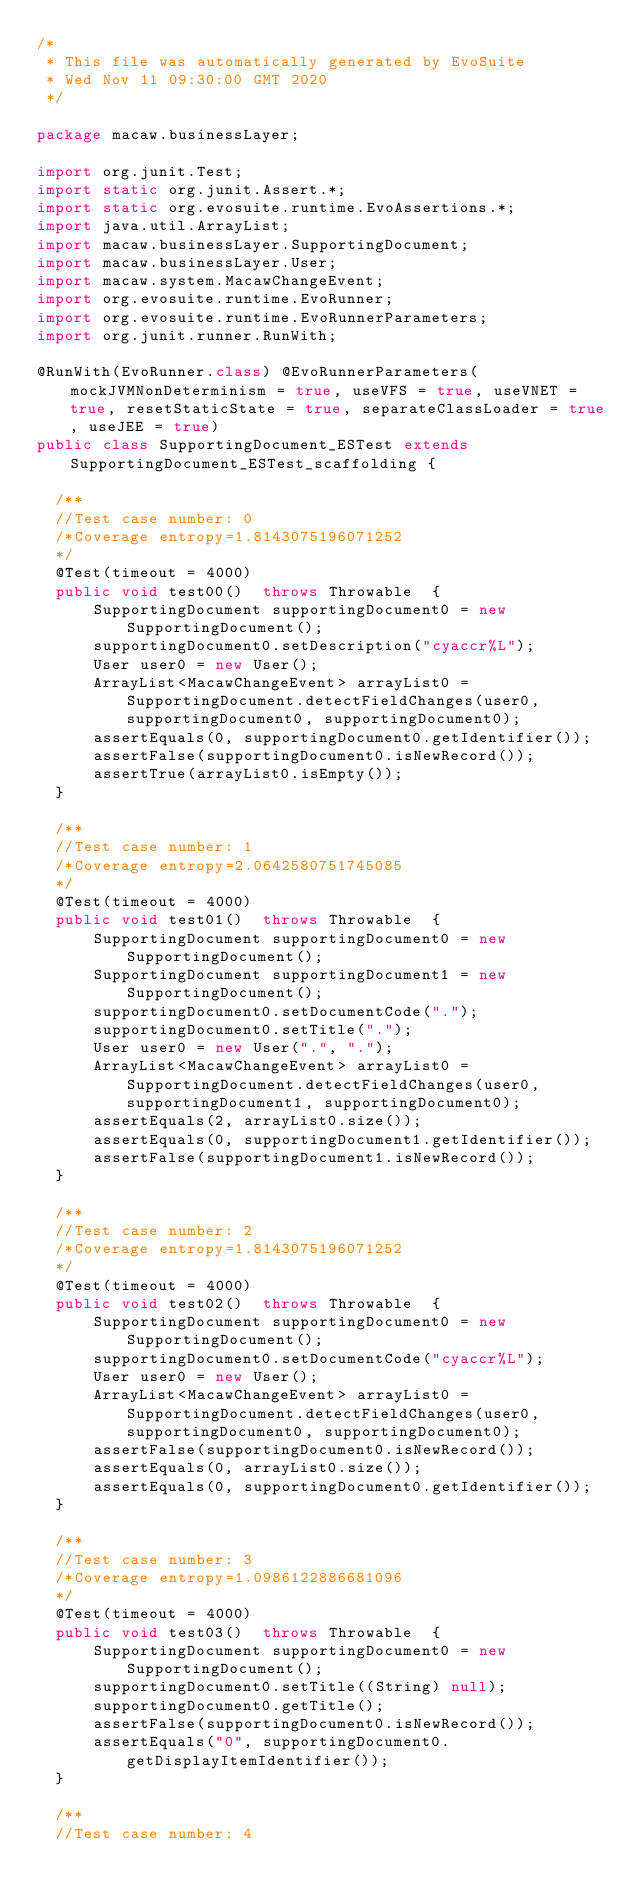Convert code to text. <code><loc_0><loc_0><loc_500><loc_500><_Java_>/*
 * This file was automatically generated by EvoSuite
 * Wed Nov 11 09:30:00 GMT 2020
 */

package macaw.businessLayer;

import org.junit.Test;
import static org.junit.Assert.*;
import static org.evosuite.runtime.EvoAssertions.*;
import java.util.ArrayList;
import macaw.businessLayer.SupportingDocument;
import macaw.businessLayer.User;
import macaw.system.MacawChangeEvent;
import org.evosuite.runtime.EvoRunner;
import org.evosuite.runtime.EvoRunnerParameters;
import org.junit.runner.RunWith;

@RunWith(EvoRunner.class) @EvoRunnerParameters(mockJVMNonDeterminism = true, useVFS = true, useVNET = true, resetStaticState = true, separateClassLoader = true, useJEE = true) 
public class SupportingDocument_ESTest extends SupportingDocument_ESTest_scaffolding {

  /**
  //Test case number: 0
  /*Coverage entropy=1.8143075196071252
  */
  @Test(timeout = 4000)
  public void test00()  throws Throwable  {
      SupportingDocument supportingDocument0 = new SupportingDocument();
      supportingDocument0.setDescription("cyaccr%L");
      User user0 = new User();
      ArrayList<MacawChangeEvent> arrayList0 = SupportingDocument.detectFieldChanges(user0, supportingDocument0, supportingDocument0);
      assertEquals(0, supportingDocument0.getIdentifier());
      assertFalse(supportingDocument0.isNewRecord());
      assertTrue(arrayList0.isEmpty());
  }

  /**
  //Test case number: 1
  /*Coverage entropy=2.0642580751745085
  */
  @Test(timeout = 4000)
  public void test01()  throws Throwable  {
      SupportingDocument supportingDocument0 = new SupportingDocument();
      SupportingDocument supportingDocument1 = new SupportingDocument();
      supportingDocument0.setDocumentCode(".");
      supportingDocument0.setTitle(".");
      User user0 = new User(".", ".");
      ArrayList<MacawChangeEvent> arrayList0 = SupportingDocument.detectFieldChanges(user0, supportingDocument1, supportingDocument0);
      assertEquals(2, arrayList0.size());
      assertEquals(0, supportingDocument1.getIdentifier());
      assertFalse(supportingDocument1.isNewRecord());
  }

  /**
  //Test case number: 2
  /*Coverage entropy=1.8143075196071252
  */
  @Test(timeout = 4000)
  public void test02()  throws Throwable  {
      SupportingDocument supportingDocument0 = new SupportingDocument();
      supportingDocument0.setDocumentCode("cyaccr%L");
      User user0 = new User();
      ArrayList<MacawChangeEvent> arrayList0 = SupportingDocument.detectFieldChanges(user0, supportingDocument0, supportingDocument0);
      assertFalse(supportingDocument0.isNewRecord());
      assertEquals(0, arrayList0.size());
      assertEquals(0, supportingDocument0.getIdentifier());
  }

  /**
  //Test case number: 3
  /*Coverage entropy=1.0986122886681096
  */
  @Test(timeout = 4000)
  public void test03()  throws Throwable  {
      SupportingDocument supportingDocument0 = new SupportingDocument();
      supportingDocument0.setTitle((String) null);
      supportingDocument0.getTitle();
      assertFalse(supportingDocument0.isNewRecord());
      assertEquals("0", supportingDocument0.getDisplayItemIdentifier());
  }

  /**
  //Test case number: 4</code> 